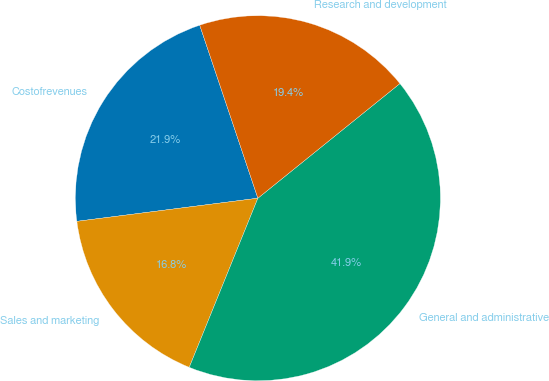<chart> <loc_0><loc_0><loc_500><loc_500><pie_chart><fcel>Costofrevenues<fcel>Sales and marketing<fcel>General and administrative<fcel>Research and development<nl><fcel>21.86%<fcel>16.84%<fcel>41.94%<fcel>19.35%<nl></chart> 